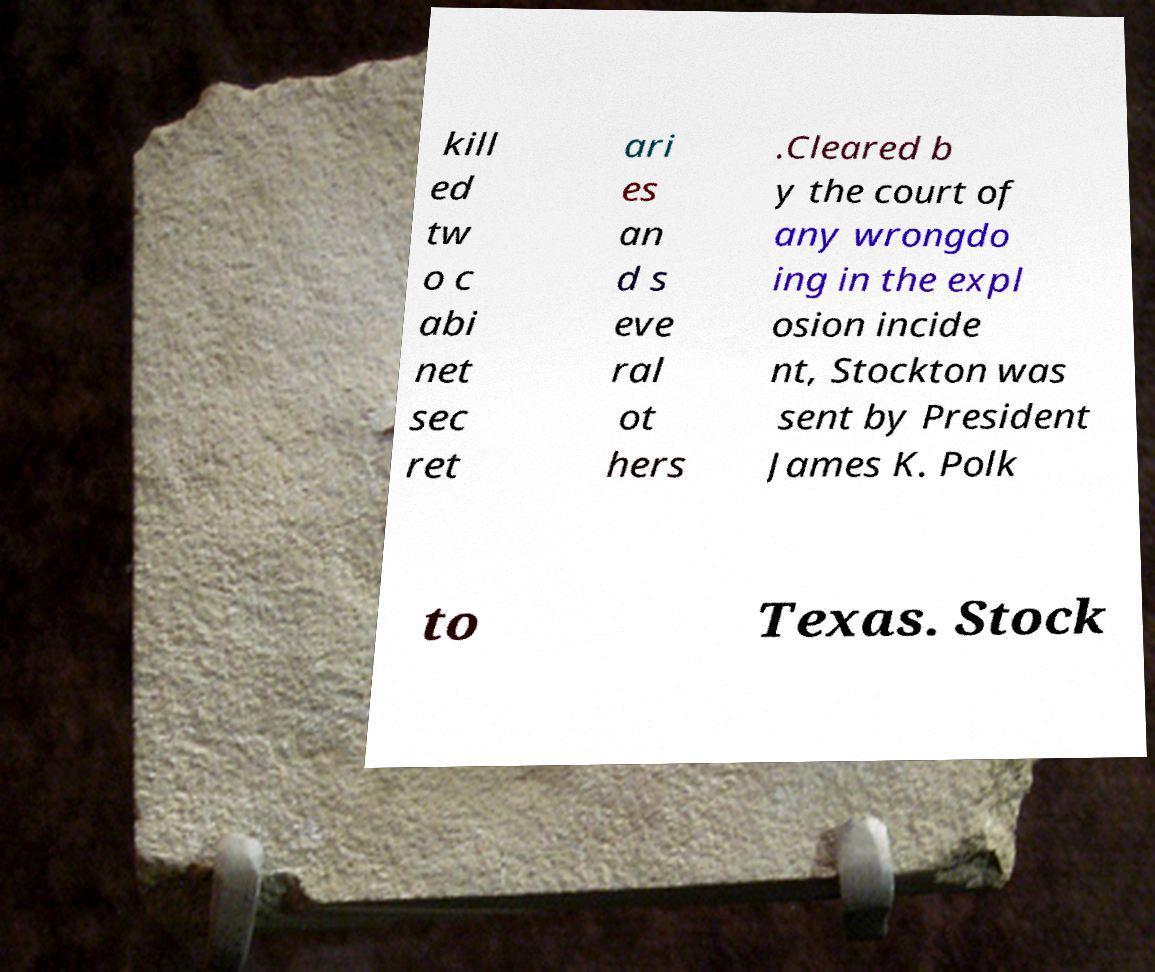I need the written content from this picture converted into text. Can you do that? kill ed tw o c abi net sec ret ari es an d s eve ral ot hers .Cleared b y the court of any wrongdo ing in the expl osion incide nt, Stockton was sent by President James K. Polk to Texas. Stock 